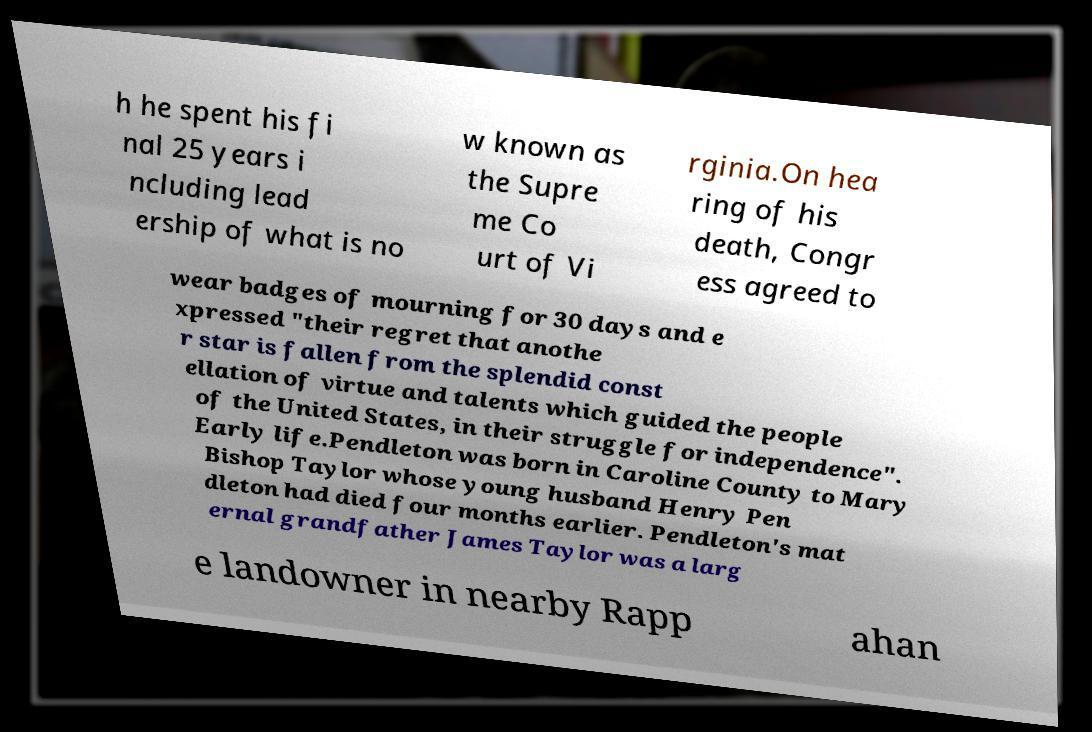Could you assist in decoding the text presented in this image and type it out clearly? h he spent his fi nal 25 years i ncluding lead ership of what is no w known as the Supre me Co urt of Vi rginia.On hea ring of his death, Congr ess agreed to wear badges of mourning for 30 days and e xpressed "their regret that anothe r star is fallen from the splendid const ellation of virtue and talents which guided the people of the United States, in their struggle for independence". Early life.Pendleton was born in Caroline County to Mary Bishop Taylor whose young husband Henry Pen dleton had died four months earlier. Pendleton's mat ernal grandfather James Taylor was a larg e landowner in nearby Rapp ahan 